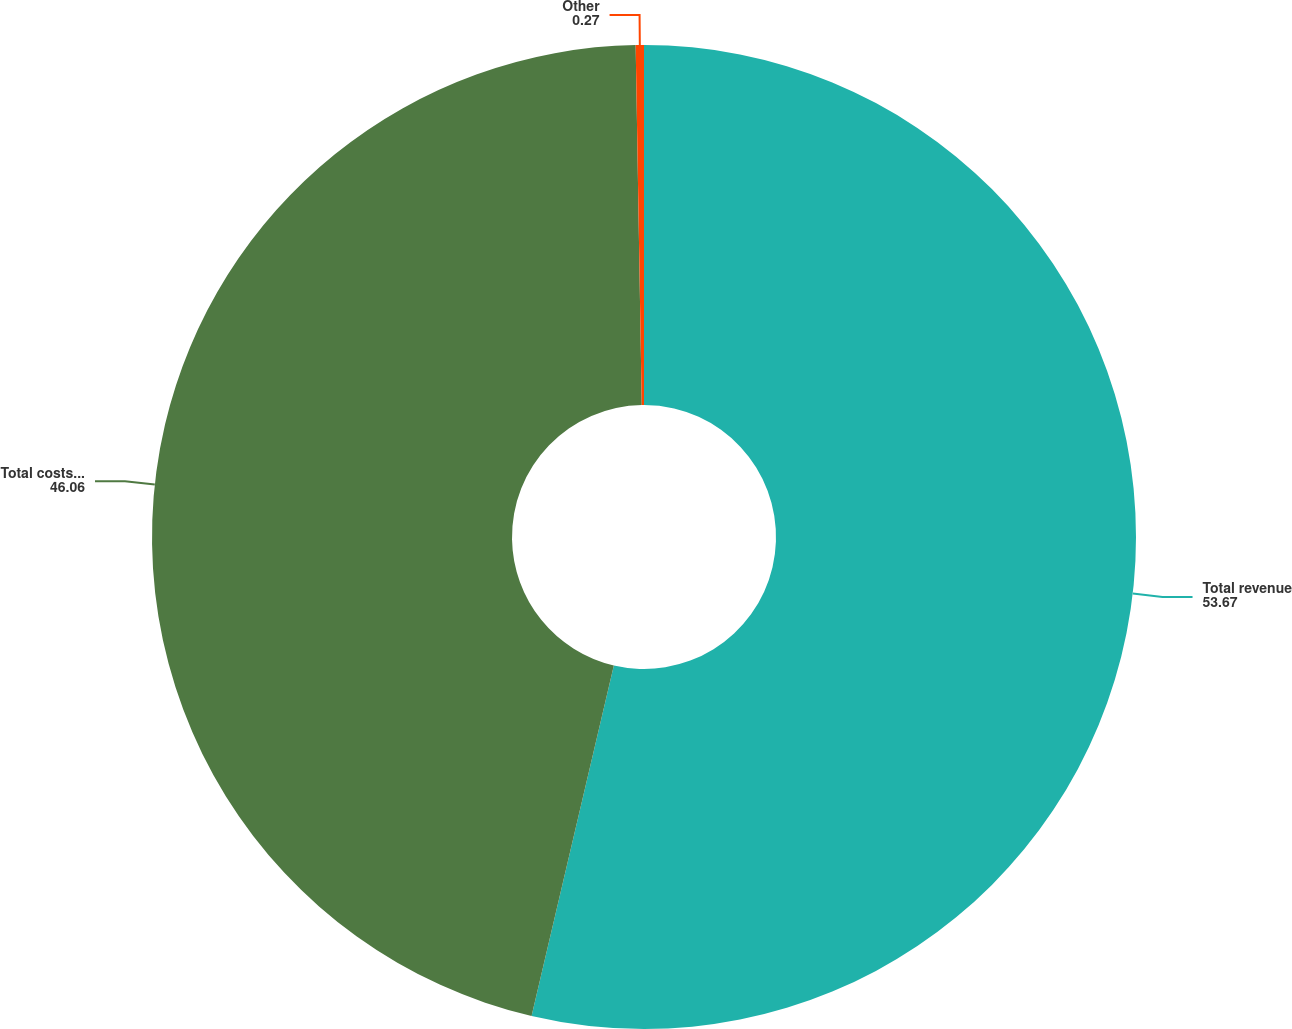Convert chart. <chart><loc_0><loc_0><loc_500><loc_500><pie_chart><fcel>Total revenue<fcel>Total costs and expenses<fcel>Other<nl><fcel>53.67%<fcel>46.06%<fcel>0.27%<nl></chart> 